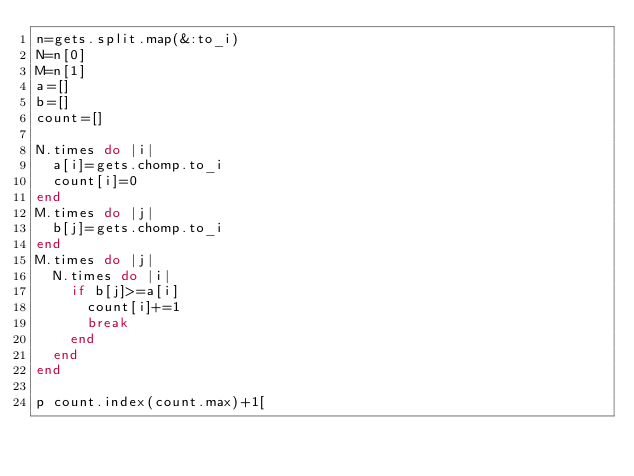Convert code to text. <code><loc_0><loc_0><loc_500><loc_500><_Ruby_>n=gets.split.map(&:to_i)
N=n[0]
M=n[1]
a=[]
b=[]
count=[]

N.times do |i|
  a[i]=gets.chomp.to_i
  count[i]=0
end
M.times do |j|
  b[j]=gets.chomp.to_i
end
M.times do |j|
  N.times do |i|
    if b[j]>=a[i]
      count[i]+=1
      break
    end
  end
end

p count.index(count.max)+1[</code> 